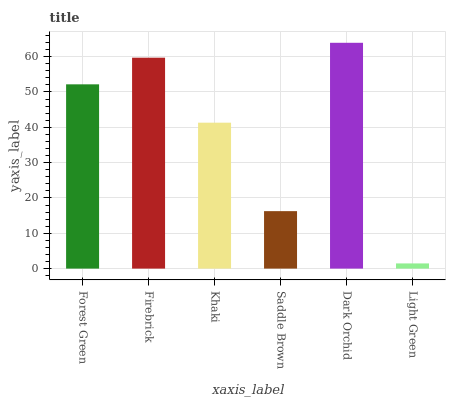Is Light Green the minimum?
Answer yes or no. Yes. Is Dark Orchid the maximum?
Answer yes or no. Yes. Is Firebrick the minimum?
Answer yes or no. No. Is Firebrick the maximum?
Answer yes or no. No. Is Firebrick greater than Forest Green?
Answer yes or no. Yes. Is Forest Green less than Firebrick?
Answer yes or no. Yes. Is Forest Green greater than Firebrick?
Answer yes or no. No. Is Firebrick less than Forest Green?
Answer yes or no. No. Is Forest Green the high median?
Answer yes or no. Yes. Is Khaki the low median?
Answer yes or no. Yes. Is Saddle Brown the high median?
Answer yes or no. No. Is Firebrick the low median?
Answer yes or no. No. 